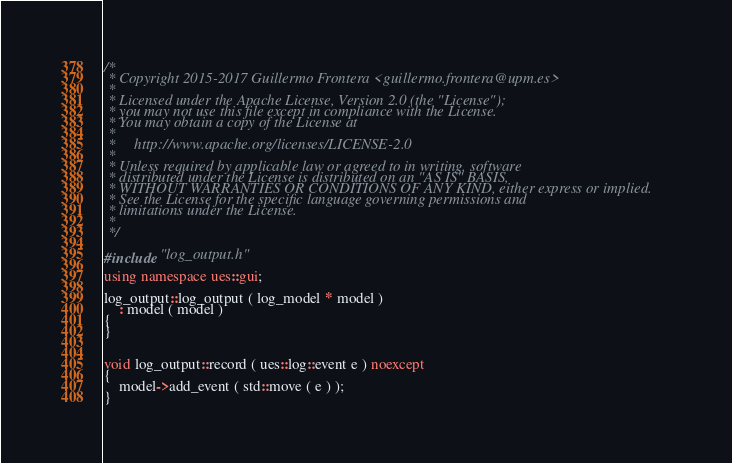Convert code to text. <code><loc_0><loc_0><loc_500><loc_500><_C++_>/*
 * Copyright 2015-2017 Guillermo Frontera <guillermo.frontera@upm.es>
 *
 * Licensed under the Apache License, Version 2.0 (the "License");
 * you may not use this file except in compliance with the License.
 * You may obtain a copy of the License at
 *
 *     http://www.apache.org/licenses/LICENSE-2.0
 *
 * Unless required by applicable law or agreed to in writing, software
 * distributed under the License is distributed on an "AS IS" BASIS,
 * WITHOUT WARRANTIES OR CONDITIONS OF ANY KIND, either express or implied.
 * See the License for the specific language governing permissions and
 * limitations under the License.
 *
 */

#include "log_output.h"

using namespace ues::gui;

log_output::log_output ( log_model * model )
    : model ( model )
{
}


void log_output::record ( ues::log::event e ) noexcept
{
    model->add_event ( std::move ( e ) );
}
</code> 